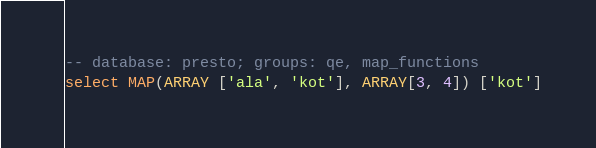<code> <loc_0><loc_0><loc_500><loc_500><_SQL_>-- database: presto; groups: qe, map_functions
select MAP(ARRAY ['ala', 'kot'], ARRAY[3, 4]) ['kot']
</code> 